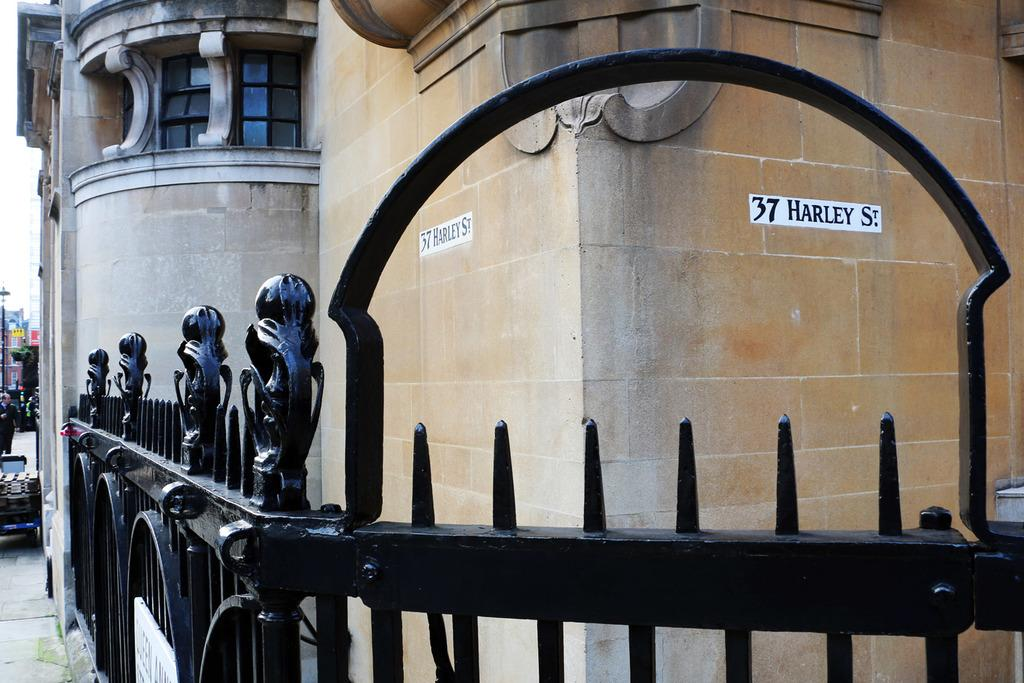What type of structure is visible in the image? There is a building with windows in the image. What is the color and material of the fencing in the image? The fencing in the image is black and made of a material that appears to be metal. What is visible at the bottom of the image? There is a floor visible at the bottom of the image. Can you describe the person in the image? There is a person on the left side of the image. What type of reward can be seen at the top of the hill in the image? There is no hill or reward present in the image. What type of joke is the person on the left side of the image telling? There is no indication of a joke being told in the image. 